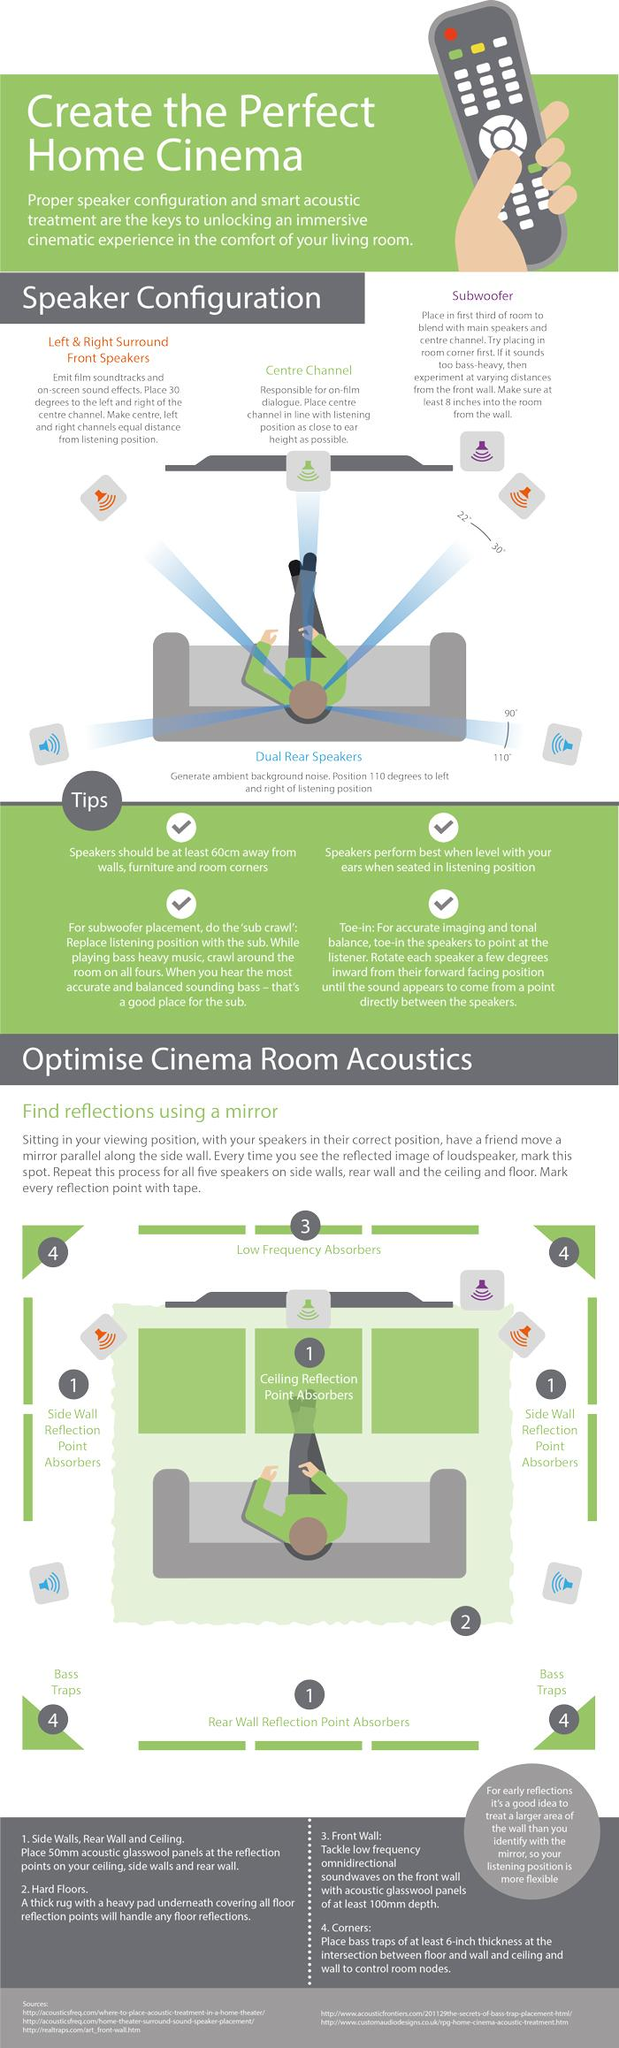Specify some key components in this picture. The single speaker placed on the right side of the viewer, the right surround speaker, the rear right dual speaker, or the subwoofer is named the subwoofer. In a home theatre setup, the center channel speaker should be placed at the center and facing the user, to provide clear and immersive audio. The direction in which the rear speakers are placed is between 90 and 110 degrees. The color of the speakers placed on the both sides of the viewer in the front is red. The direction in which the surround front speakers are to be placed is 22-30 degrees. 